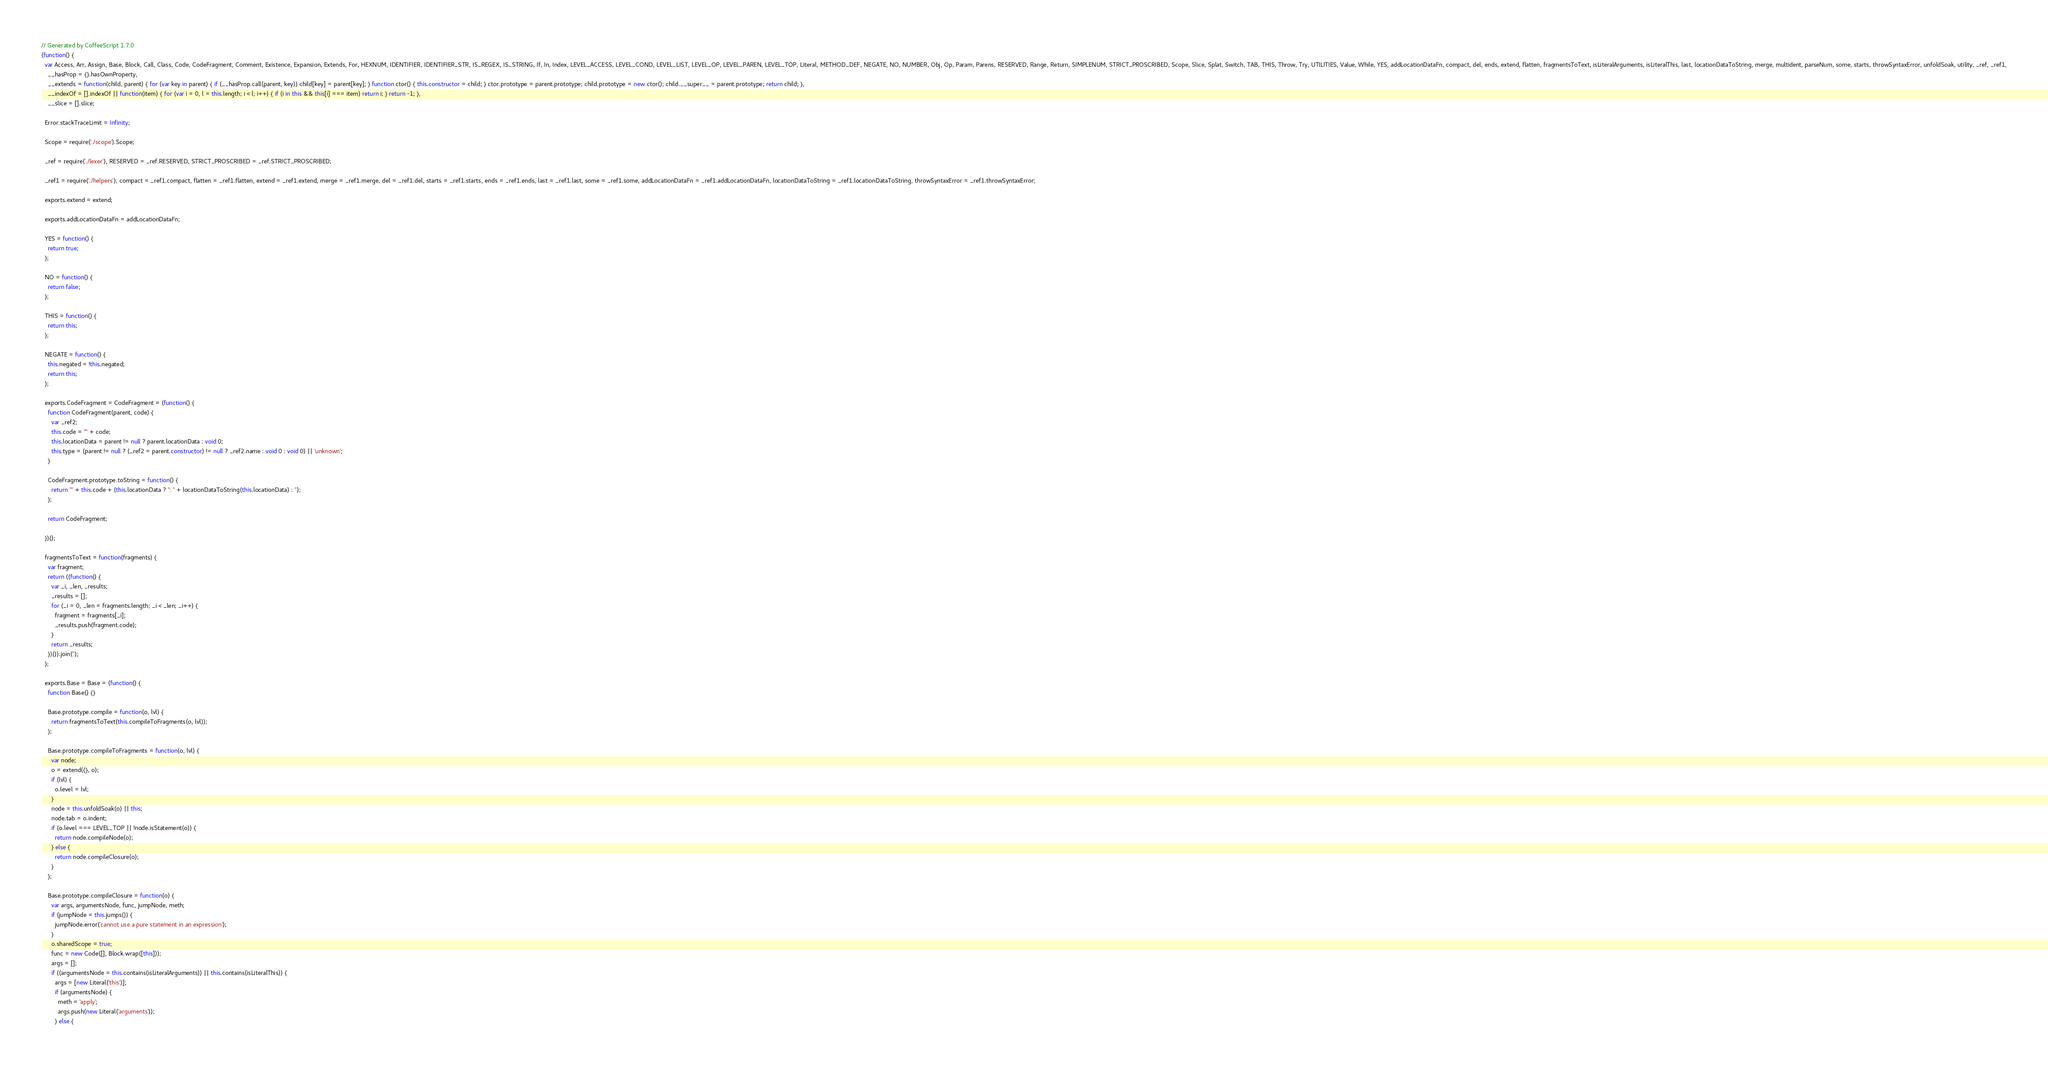<code> <loc_0><loc_0><loc_500><loc_500><_JavaScript_>// Generated by CoffeeScript 1.7.0
(function() {
  var Access, Arr, Assign, Base, Block, Call, Class, Code, CodeFragment, Comment, Existence, Expansion, Extends, For, HEXNUM, IDENTIFIER, IDENTIFIER_STR, IS_REGEX, IS_STRING, If, In, Index, LEVEL_ACCESS, LEVEL_COND, LEVEL_LIST, LEVEL_OP, LEVEL_PAREN, LEVEL_TOP, Literal, METHOD_DEF, NEGATE, NO, NUMBER, Obj, Op, Param, Parens, RESERVED, Range, Return, SIMPLENUM, STRICT_PROSCRIBED, Scope, Slice, Splat, Switch, TAB, THIS, Throw, Try, UTILITIES, Value, While, YES, addLocationDataFn, compact, del, ends, extend, flatten, fragmentsToText, isLiteralArguments, isLiteralThis, last, locationDataToString, merge, multident, parseNum, some, starts, throwSyntaxError, unfoldSoak, utility, _ref, _ref1,
    __hasProp = {}.hasOwnProperty,
    __extends = function(child, parent) { for (var key in parent) { if (__hasProp.call(parent, key)) child[key] = parent[key]; } function ctor() { this.constructor = child; } ctor.prototype = parent.prototype; child.prototype = new ctor(); child.__super__ = parent.prototype; return child; },
    __indexOf = [].indexOf || function(item) { for (var i = 0, l = this.length; i < l; i++) { if (i in this && this[i] === item) return i; } return -1; },
    __slice = [].slice;

  Error.stackTraceLimit = Infinity;

  Scope = require('./scope').Scope;

  _ref = require('./lexer'), RESERVED = _ref.RESERVED, STRICT_PROSCRIBED = _ref.STRICT_PROSCRIBED;

  _ref1 = require('./helpers'), compact = _ref1.compact, flatten = _ref1.flatten, extend = _ref1.extend, merge = _ref1.merge, del = _ref1.del, starts = _ref1.starts, ends = _ref1.ends, last = _ref1.last, some = _ref1.some, addLocationDataFn = _ref1.addLocationDataFn, locationDataToString = _ref1.locationDataToString, throwSyntaxError = _ref1.throwSyntaxError;

  exports.extend = extend;

  exports.addLocationDataFn = addLocationDataFn;

  YES = function() {
    return true;
  };

  NO = function() {
    return false;
  };

  THIS = function() {
    return this;
  };

  NEGATE = function() {
    this.negated = !this.negated;
    return this;
  };

  exports.CodeFragment = CodeFragment = (function() {
    function CodeFragment(parent, code) {
      var _ref2;
      this.code = "" + code;
      this.locationData = parent != null ? parent.locationData : void 0;
      this.type = (parent != null ? (_ref2 = parent.constructor) != null ? _ref2.name : void 0 : void 0) || 'unknown';
    }

    CodeFragment.prototype.toString = function() {
      return "" + this.code + (this.locationData ? ": " + locationDataToString(this.locationData) : '');
    };

    return CodeFragment;

  })();

  fragmentsToText = function(fragments) {
    var fragment;
    return ((function() {
      var _i, _len, _results;
      _results = [];
      for (_i = 0, _len = fragments.length; _i < _len; _i++) {
        fragment = fragments[_i];
        _results.push(fragment.code);
      }
      return _results;
    })()).join('');
  };

  exports.Base = Base = (function() {
    function Base() {}

    Base.prototype.compile = function(o, lvl) {
      return fragmentsToText(this.compileToFragments(o, lvl));
    };

    Base.prototype.compileToFragments = function(o, lvl) {
      var node;
      o = extend({}, o);
      if (lvl) {
        o.level = lvl;
      }
      node = this.unfoldSoak(o) || this;
      node.tab = o.indent;
      if (o.level === LEVEL_TOP || !node.isStatement(o)) {
        return node.compileNode(o);
      } else {
        return node.compileClosure(o);
      }
    };

    Base.prototype.compileClosure = function(o) {
      var args, argumentsNode, func, jumpNode, meth;
      if (jumpNode = this.jumps()) {
        jumpNode.error('cannot use a pure statement in an expression');
      }
      o.sharedScope = true;
      func = new Code([], Block.wrap([this]));
      args = [];
      if ((argumentsNode = this.contains(isLiteralArguments)) || this.contains(isLiteralThis)) {
        args = [new Literal('this')];
        if (argumentsNode) {
          meth = 'apply';
          args.push(new Literal('arguments'));
        } else {</code> 